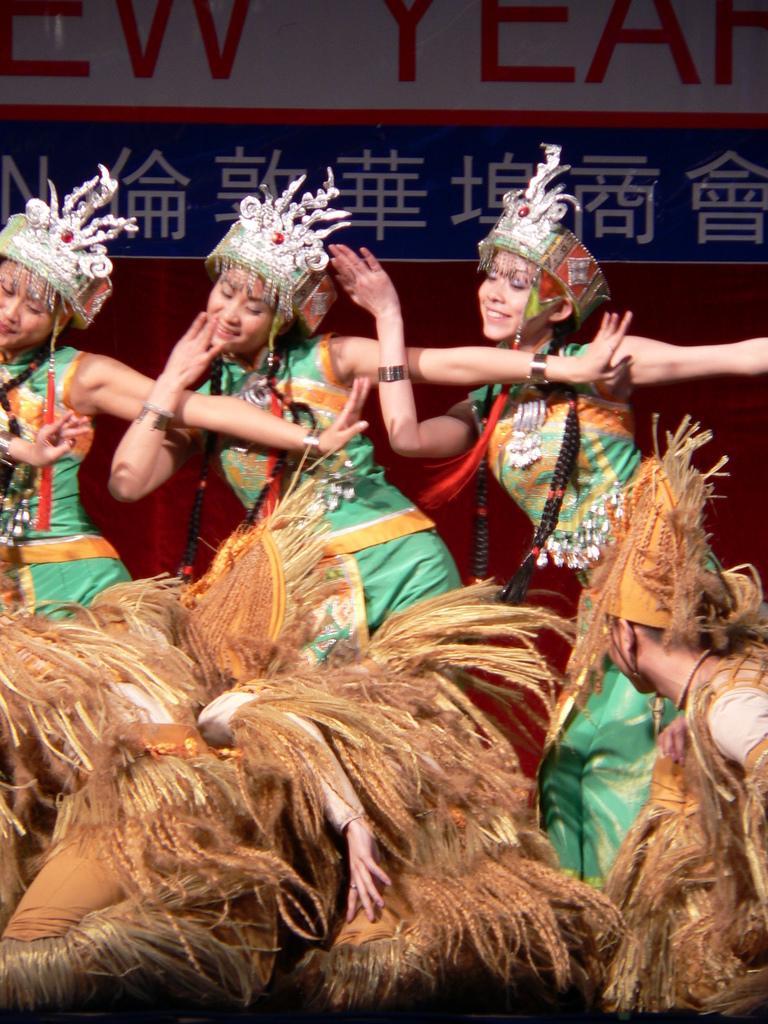Can you describe this image briefly? In this image we can see a group of people on the floor wearing the costumes. On the backside we can see a curtain and a board with some text on it. 